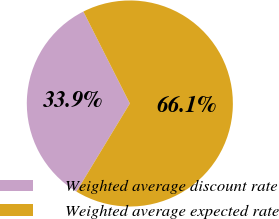Convert chart to OTSL. <chart><loc_0><loc_0><loc_500><loc_500><pie_chart><fcel>Weighted average discount rate<fcel>Weighted average expected rate<nl><fcel>33.88%<fcel>66.12%<nl></chart> 